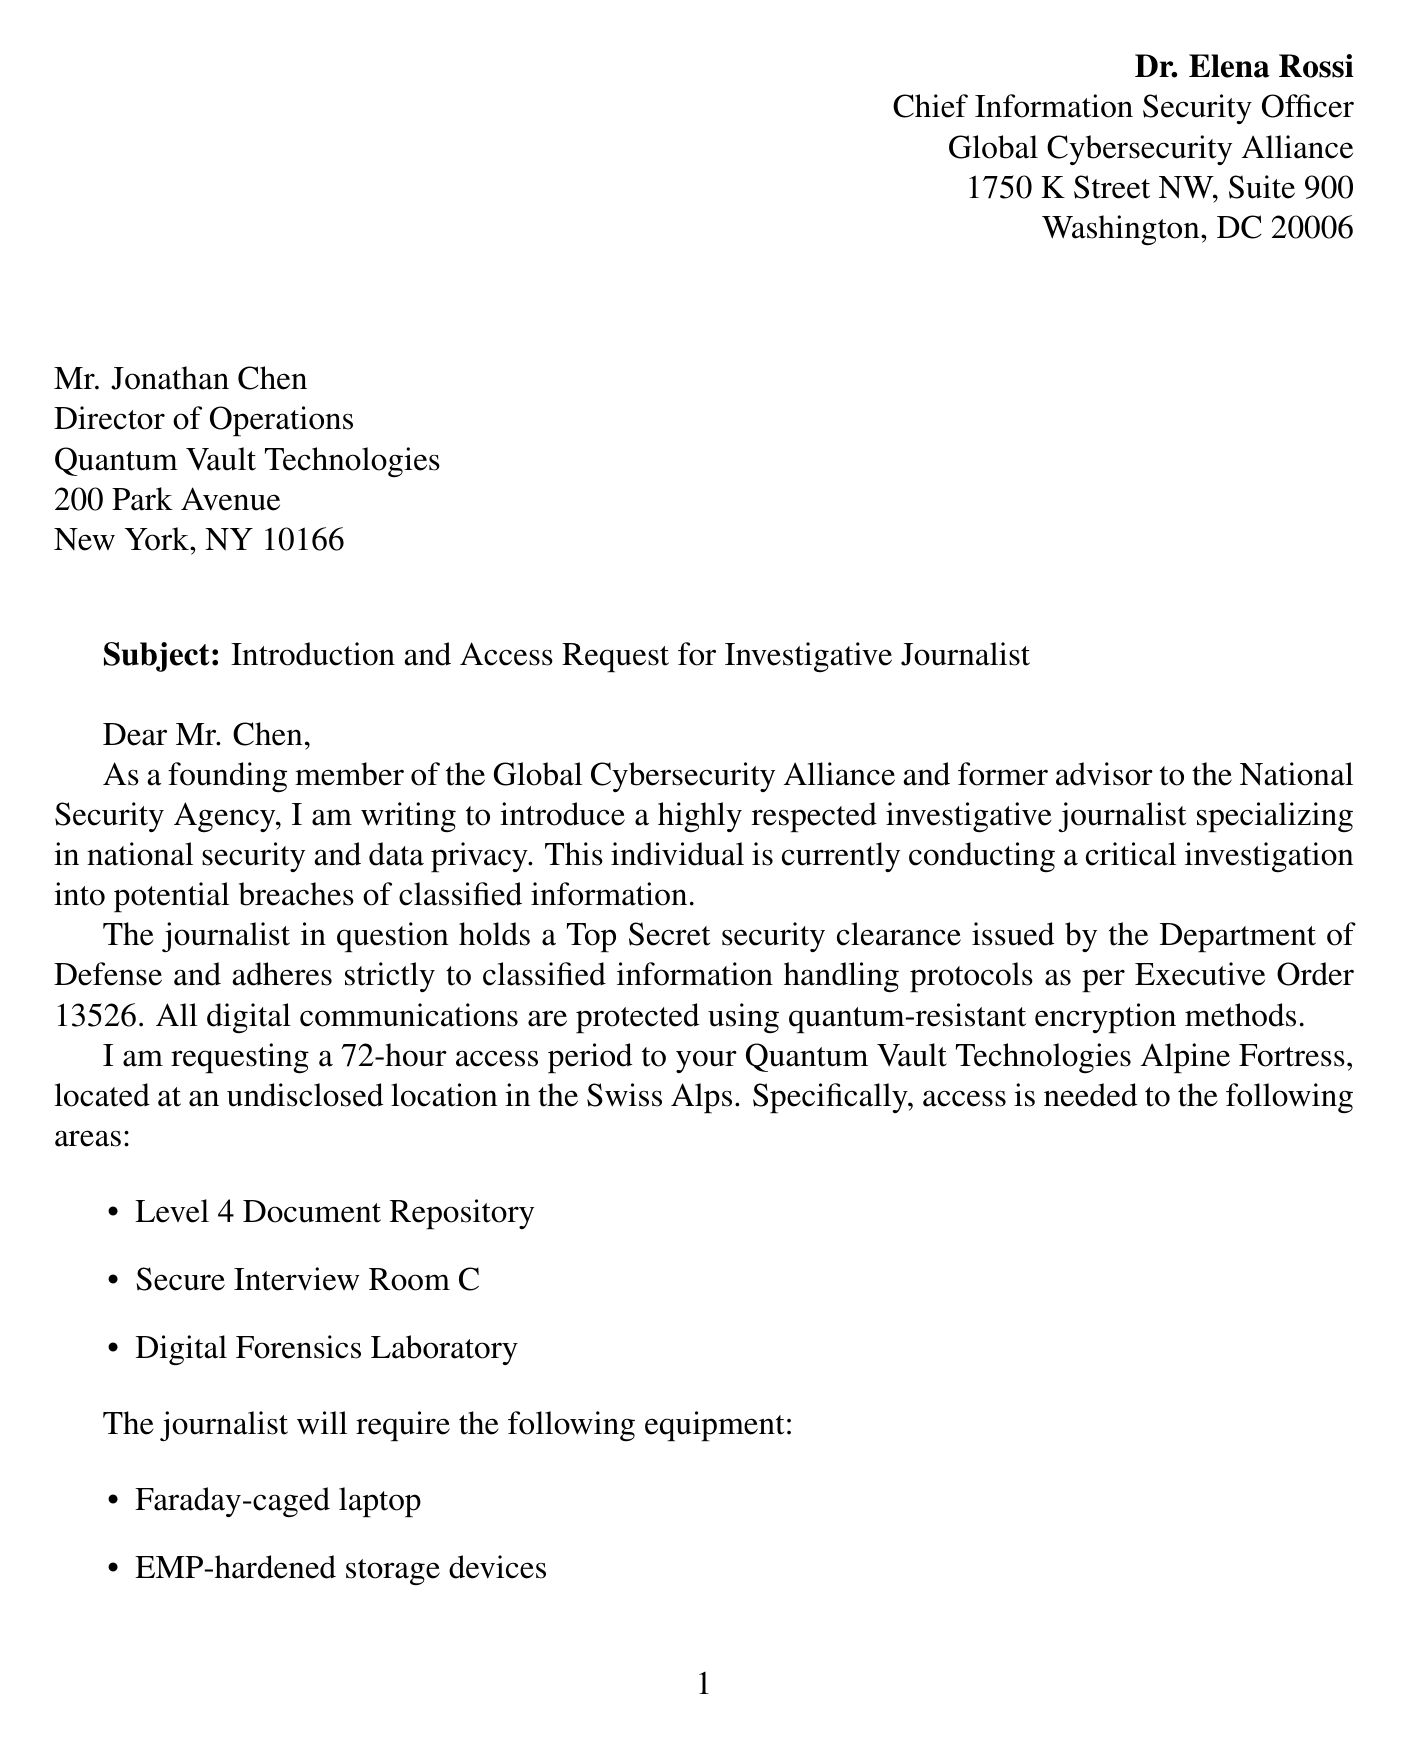what is the name of the sender? The sender's name is provided in the header of the letter.
Answer: Dr. Elena Rossi what is the position of Mr. Jonathan Chen? Mr. Jonathan Chen's position is mentioned in the recipient section of the letter.
Answer: Director of Operations which organization is Dr. Elena Rossi affiliated with? The document states Dr. Elena Rossi's organization in the header.
Answer: Global Cybersecurity Alliance what location is the Quantum Vault Technologies facility situated in? The location of the facility is specifically stated in the access request details.
Answer: Swiss Alps how long is the requested access period? The duration of access is noted in the access request details of the letter.
Answer: 72-hour access period what security clearance does the journalist hold? The security clearance is mentioned in the security assurances section.
Answer: Top Secret which communication methods will be used for the investigation? The document outlines the encryption methods to be utilized in the security assurances section.
Answer: quantum-resistant encryption methods what type of agreement will the journalist sign? The document specifies the type of agreement in the confidentiality agreement section.
Answer: non-disclosure agreement what is the purpose of the request? The purpose of the request is outlined in the introduction paragraph of the letter.
Answer: conducting a critical investigation into potential breaches of classified information 